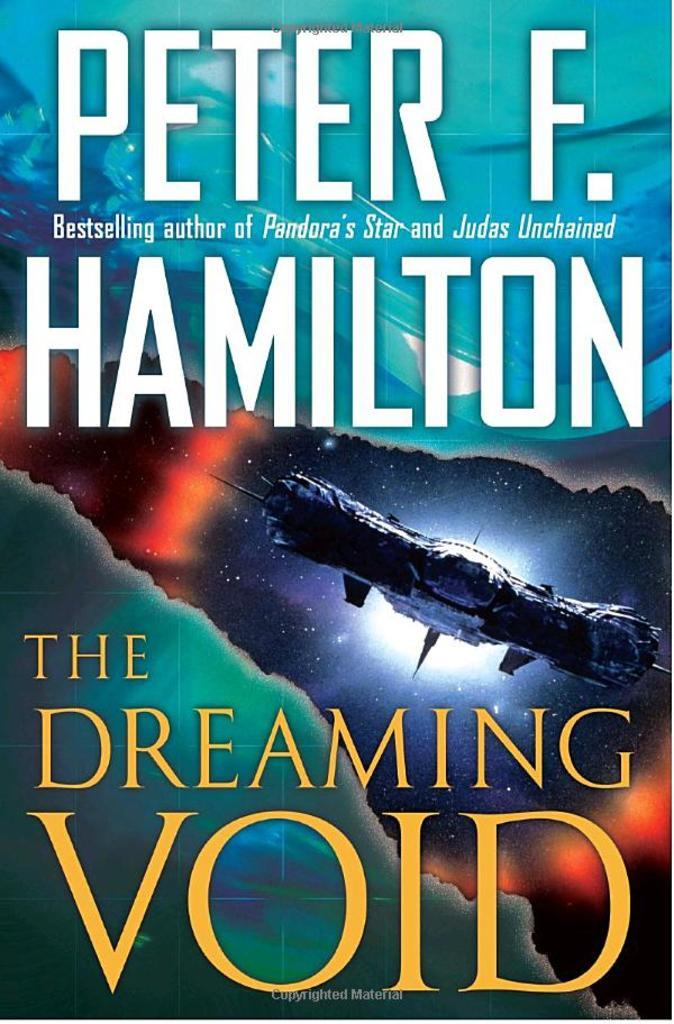<image>
Create a compact narrative representing the image presented. A book cover for a sci-fi novel called The Dreaming Void. 